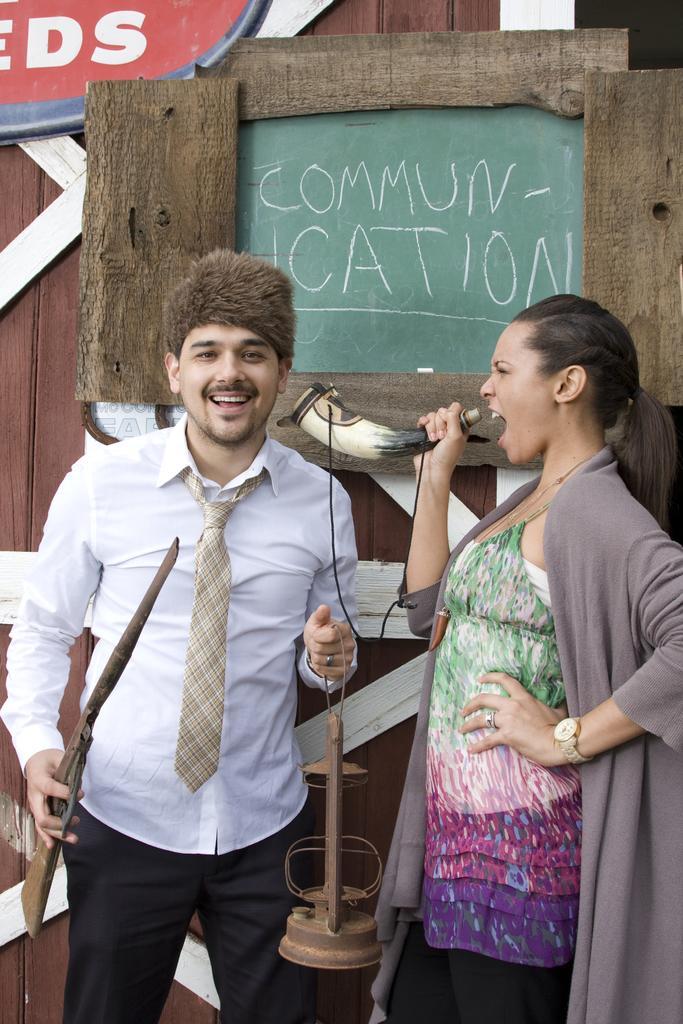Describe this image in one or two sentences. In the image in the center we can see two persons were standing and they were smiling,which we can see on their faces. And we can see they were holding some objects. In the background there is a wooden wall,banner,board and few other objects. 